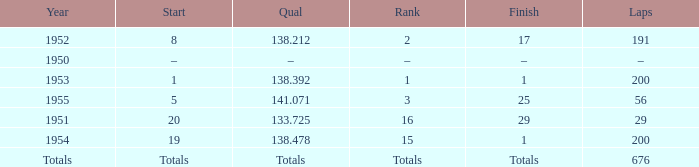How many laps was qualifier of 138.212? 191.0. 